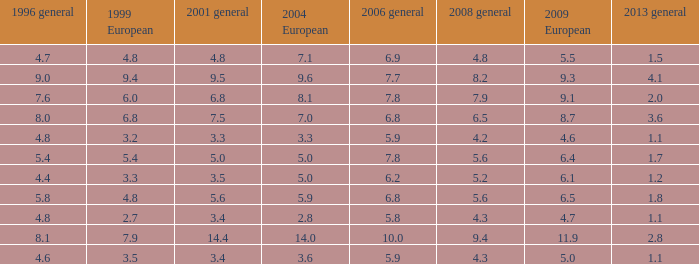What is the lowest value for 2004 European when 1999 European is 3.3 and less than 4.4 in 1996 general? None. 